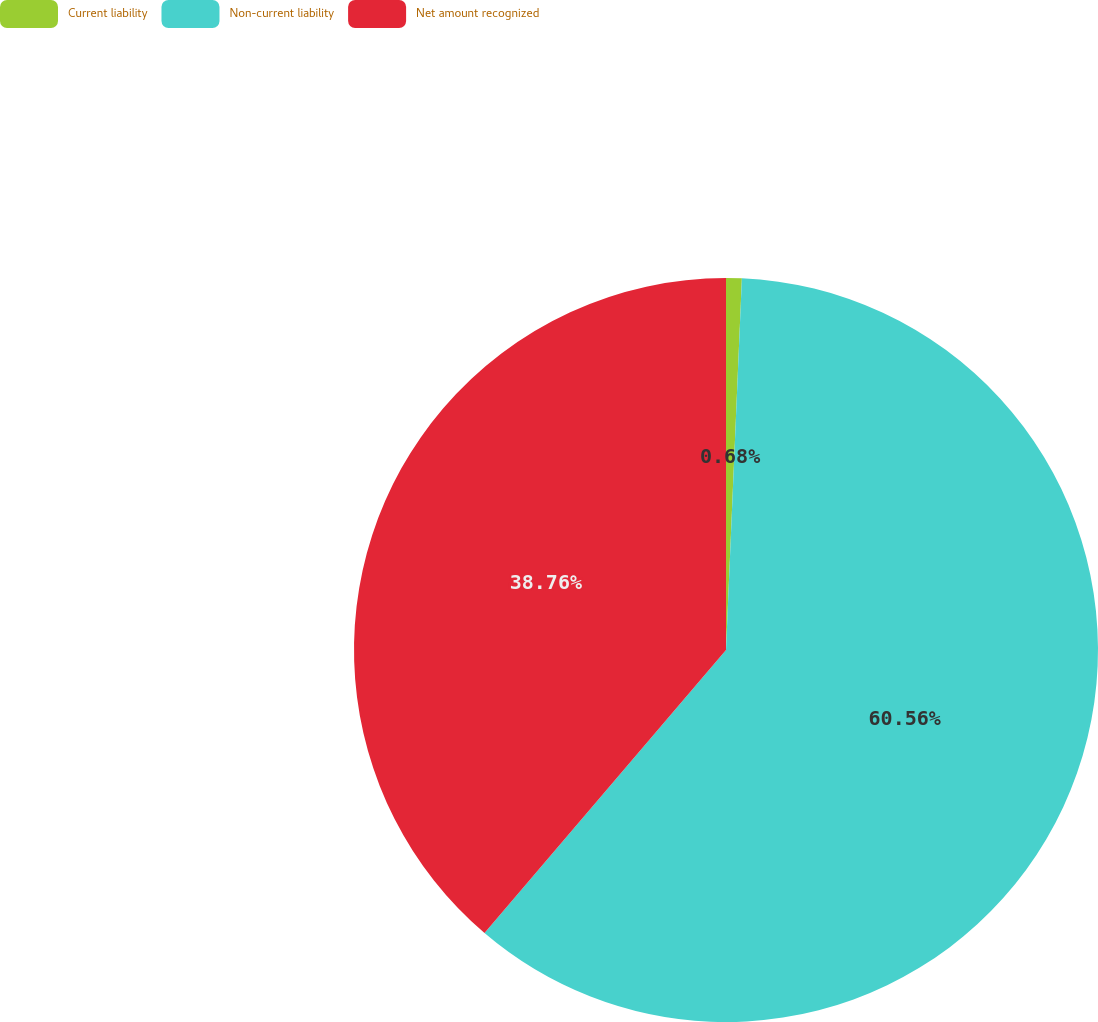Convert chart to OTSL. <chart><loc_0><loc_0><loc_500><loc_500><pie_chart><fcel>Current liability<fcel>Non-current liability<fcel>Net amount recognized<nl><fcel>0.68%<fcel>60.57%<fcel>38.76%<nl></chart> 